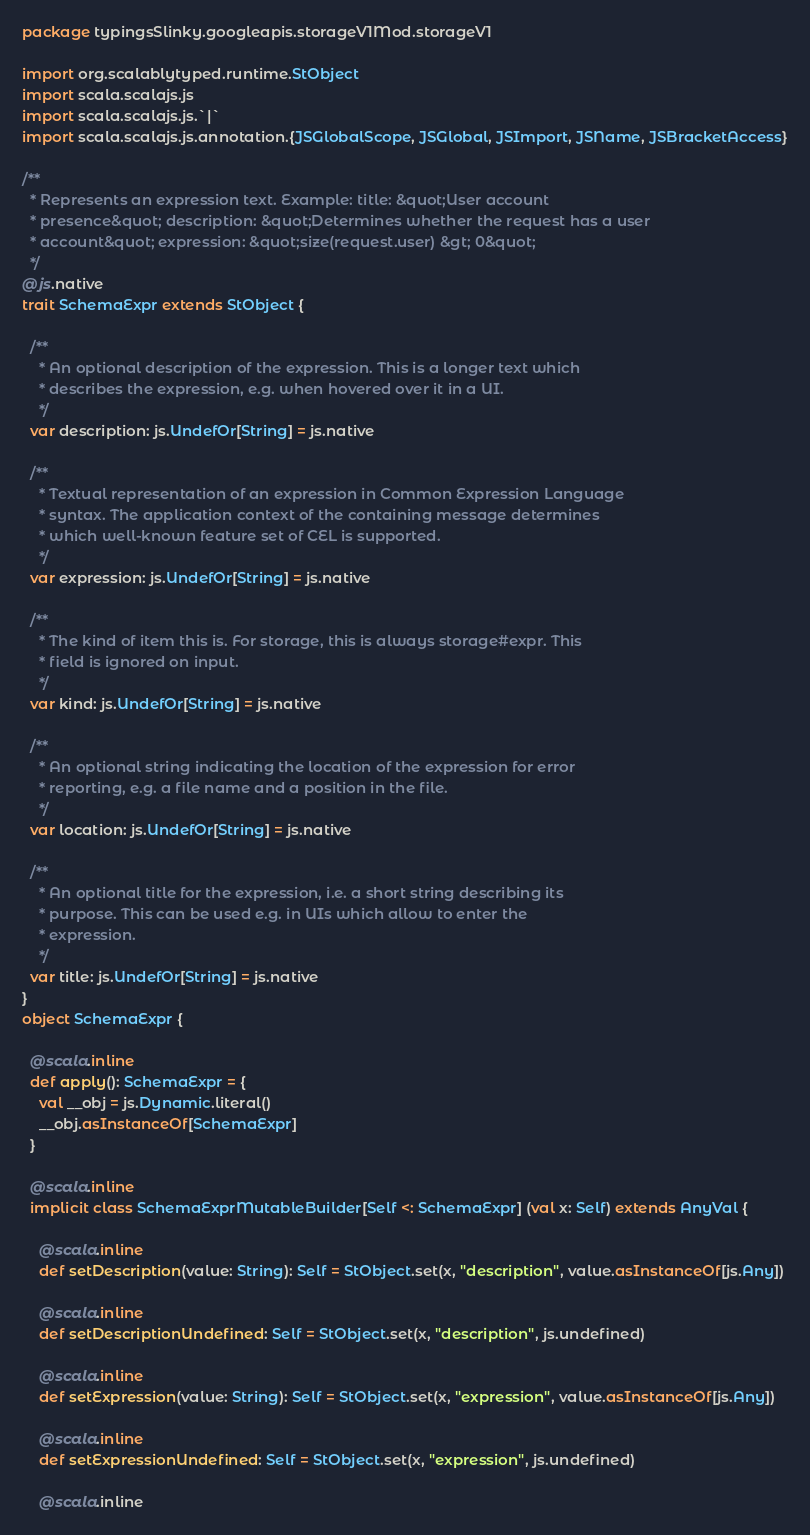<code> <loc_0><loc_0><loc_500><loc_500><_Scala_>package typingsSlinky.googleapis.storageV1Mod.storageV1

import org.scalablytyped.runtime.StObject
import scala.scalajs.js
import scala.scalajs.js.`|`
import scala.scalajs.js.annotation.{JSGlobalScope, JSGlobal, JSImport, JSName, JSBracketAccess}

/**
  * Represents an expression text. Example: title: &quot;User account
  * presence&quot; description: &quot;Determines whether the request has a user
  * account&quot; expression: &quot;size(request.user) &gt; 0&quot;
  */
@js.native
trait SchemaExpr extends StObject {
  
  /**
    * An optional description of the expression. This is a longer text which
    * describes the expression, e.g. when hovered over it in a UI.
    */
  var description: js.UndefOr[String] = js.native
  
  /**
    * Textual representation of an expression in Common Expression Language
    * syntax. The application context of the containing message determines
    * which well-known feature set of CEL is supported.
    */
  var expression: js.UndefOr[String] = js.native
  
  /**
    * The kind of item this is. For storage, this is always storage#expr. This
    * field is ignored on input.
    */
  var kind: js.UndefOr[String] = js.native
  
  /**
    * An optional string indicating the location of the expression for error
    * reporting, e.g. a file name and a position in the file.
    */
  var location: js.UndefOr[String] = js.native
  
  /**
    * An optional title for the expression, i.e. a short string describing its
    * purpose. This can be used e.g. in UIs which allow to enter the
    * expression.
    */
  var title: js.UndefOr[String] = js.native
}
object SchemaExpr {
  
  @scala.inline
  def apply(): SchemaExpr = {
    val __obj = js.Dynamic.literal()
    __obj.asInstanceOf[SchemaExpr]
  }
  
  @scala.inline
  implicit class SchemaExprMutableBuilder[Self <: SchemaExpr] (val x: Self) extends AnyVal {
    
    @scala.inline
    def setDescription(value: String): Self = StObject.set(x, "description", value.asInstanceOf[js.Any])
    
    @scala.inline
    def setDescriptionUndefined: Self = StObject.set(x, "description", js.undefined)
    
    @scala.inline
    def setExpression(value: String): Self = StObject.set(x, "expression", value.asInstanceOf[js.Any])
    
    @scala.inline
    def setExpressionUndefined: Self = StObject.set(x, "expression", js.undefined)
    
    @scala.inline</code> 